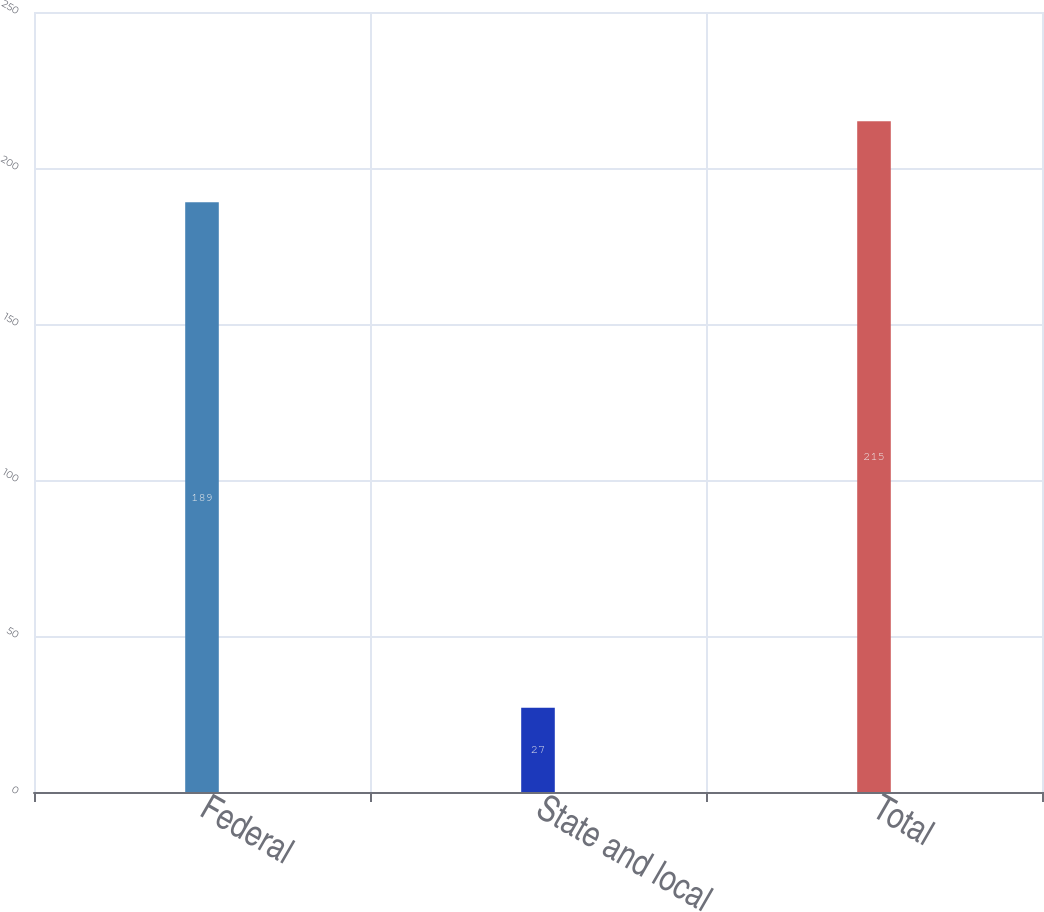Convert chart. <chart><loc_0><loc_0><loc_500><loc_500><bar_chart><fcel>Federal<fcel>State and local<fcel>Total<nl><fcel>189<fcel>27<fcel>215<nl></chart> 